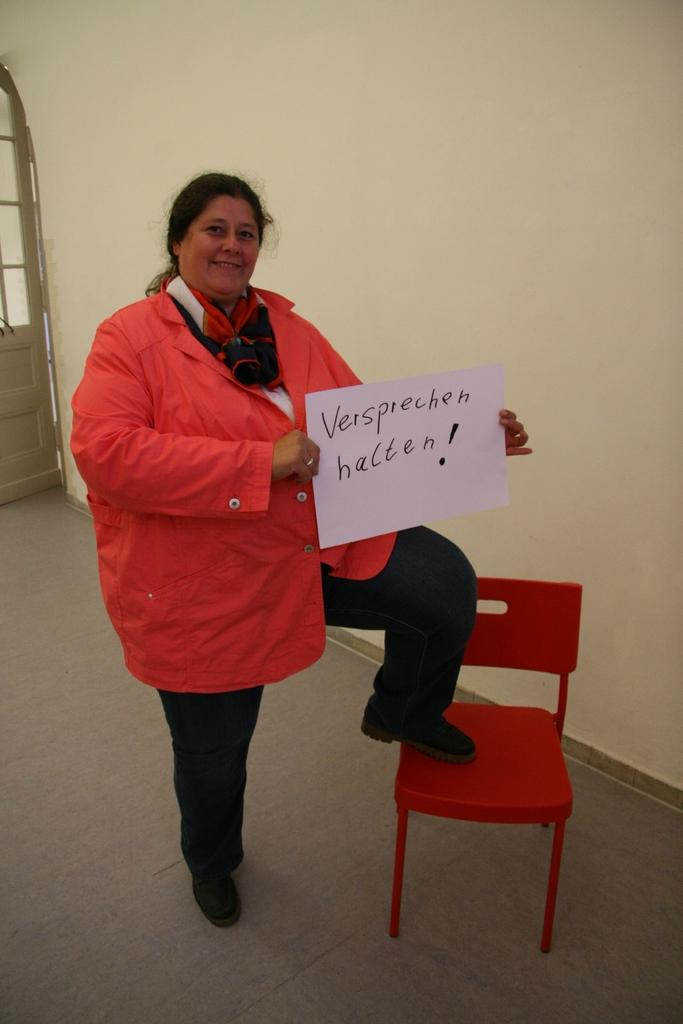Who is present in the image? There is a lady in the image. What is the lady holding? The lady is holding a paper. What can be seen on the paper? Something is written on the paper. How is the lady positioned in the image? The lady has one leg on a chair. What can be seen in the background of the image? There is a wall and a part of a door visible in the background. Can you tell me how many kittens are playing with the paste on the quarter in the image? There are no kittens, paste, or quarters present in the image. 